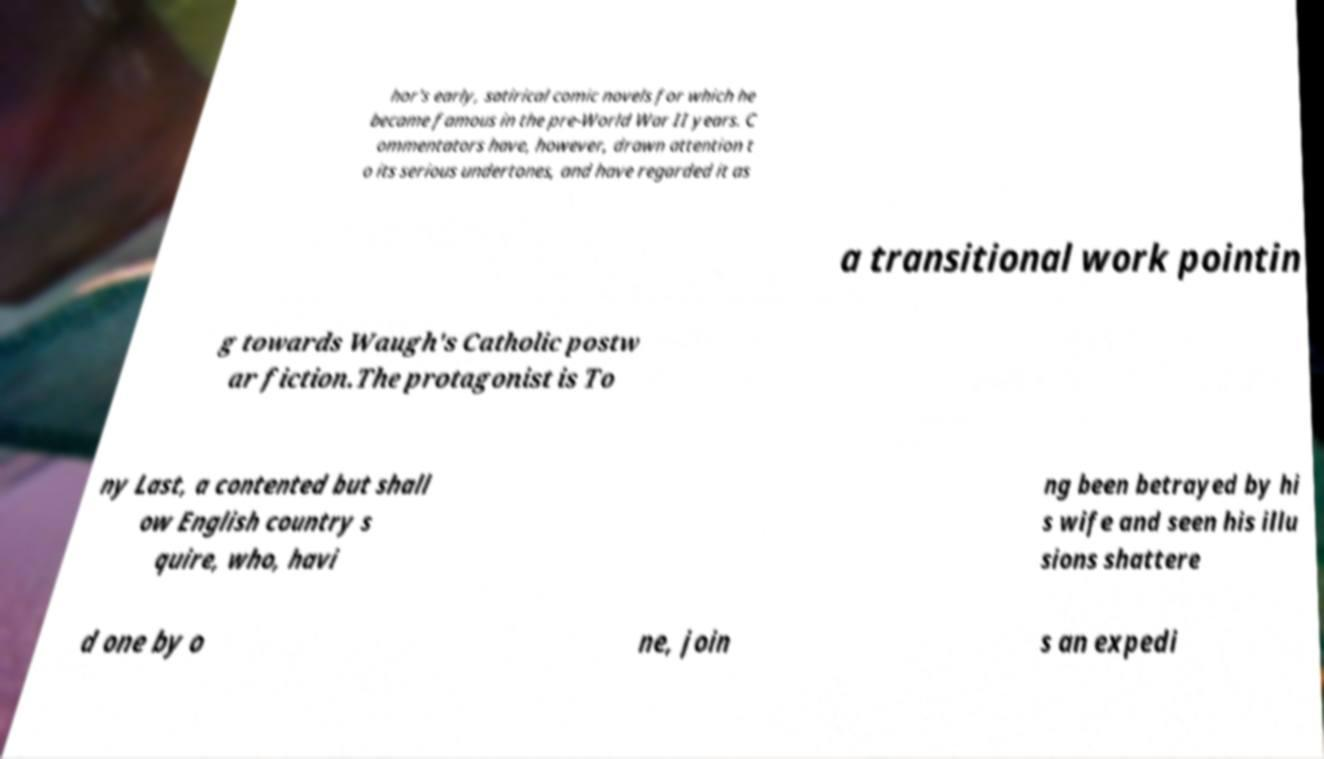I need the written content from this picture converted into text. Can you do that? hor's early, satirical comic novels for which he became famous in the pre-World War II years. C ommentators have, however, drawn attention t o its serious undertones, and have regarded it as a transitional work pointin g towards Waugh's Catholic postw ar fiction.The protagonist is To ny Last, a contented but shall ow English country s quire, who, havi ng been betrayed by hi s wife and seen his illu sions shattere d one by o ne, join s an expedi 